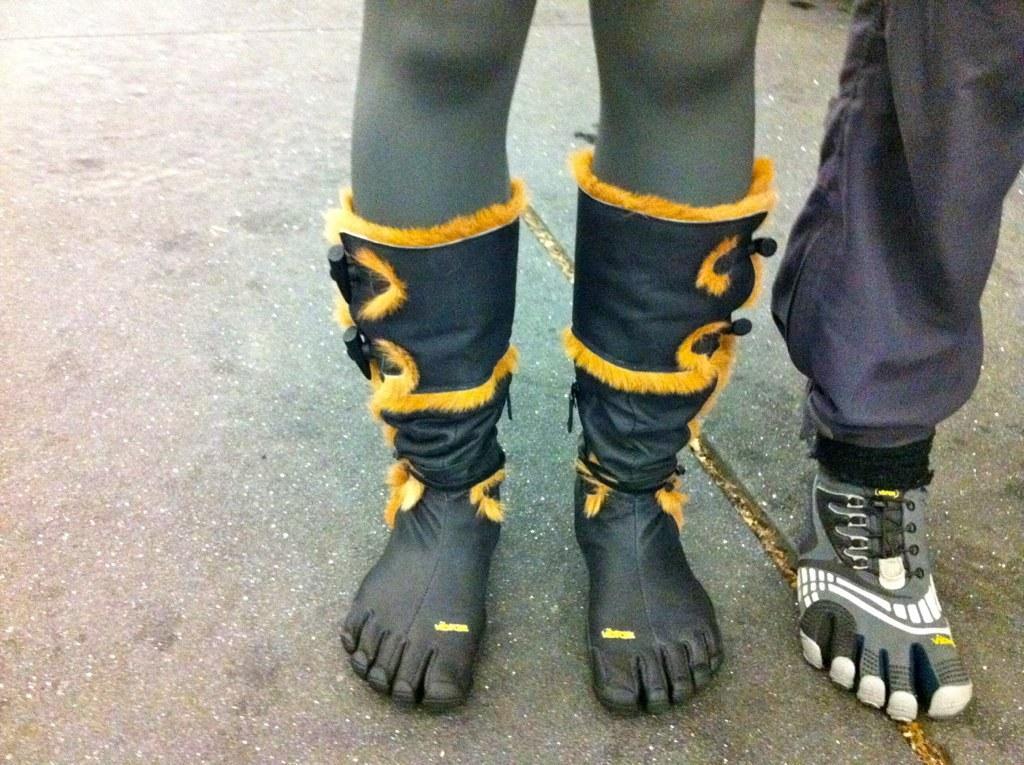In one or two sentences, can you explain what this image depicts? In this picture we can see there are legs of two persons and the persons are standing on the road. 